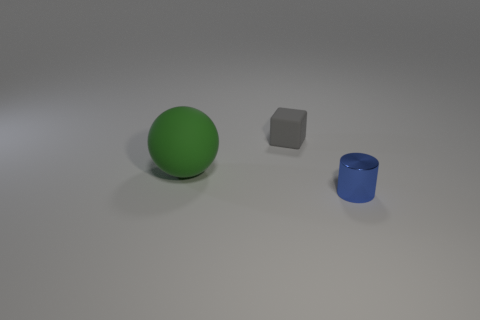There is a tiny blue metal cylinder; how many small blocks are behind it? 1 